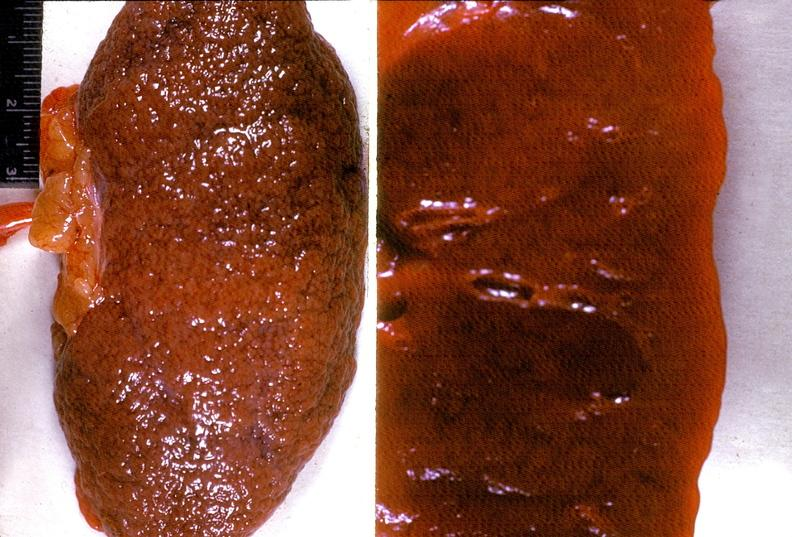does close-up excellent example of interosseous muscle atrophy show kidney, arteriolonephrosclerosis, malignant hypertension?
Answer the question using a single word or phrase. No 